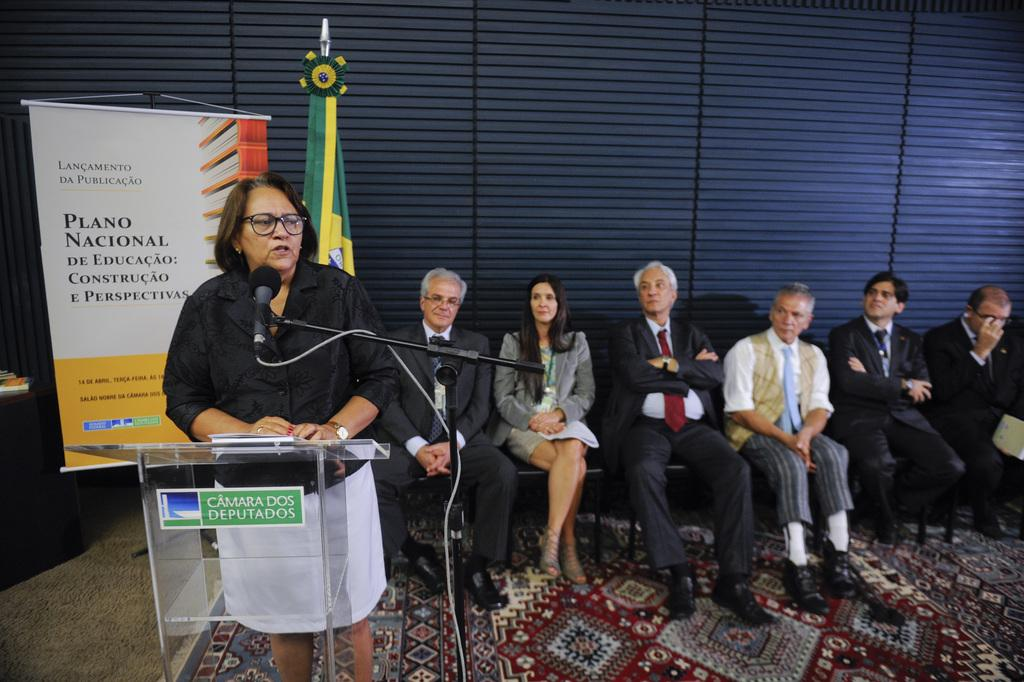How many people are in the image? There is a group of people in the image. What are some of the people doing in the image? Some people are sitting on chairs, and one woman is standing. What objects are present in the image that might be used for speaking or presenting? There is a podium and a microphone in the image. What can be seen in the background of the image? There is a flag and a poster in the background of the image. What time does the clock in the image show? There is no clock present in the image. 